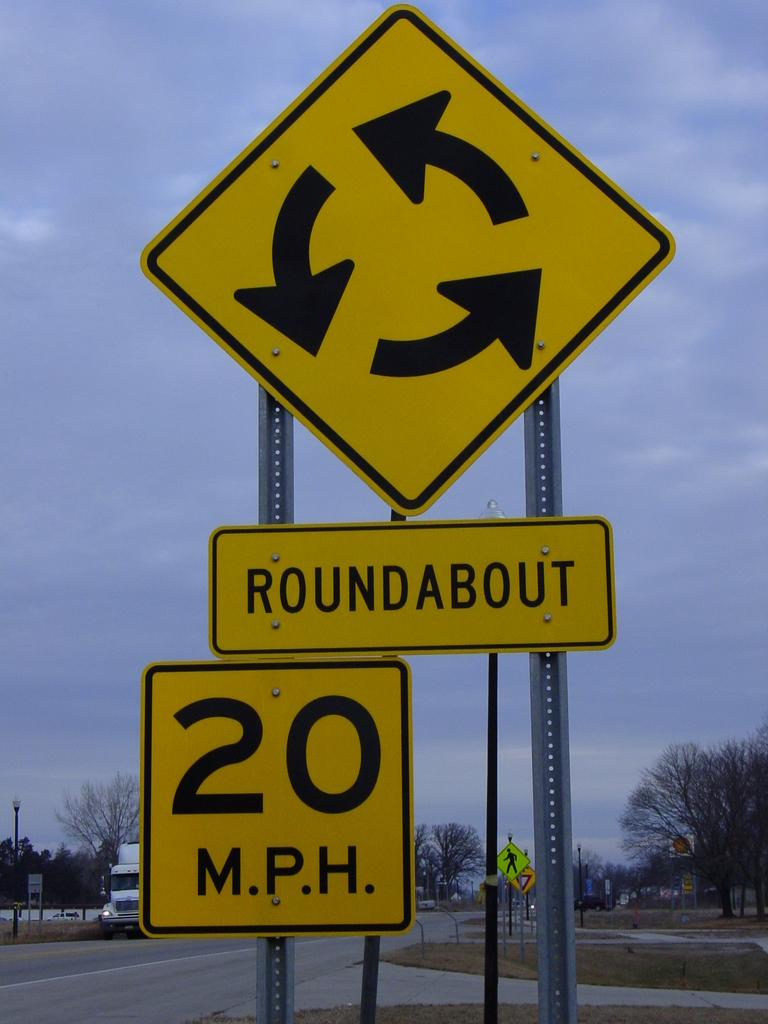<image>
Relay a brief, clear account of the picture shown. A sign for a roundabout says that people should go 20 miles per hour. 